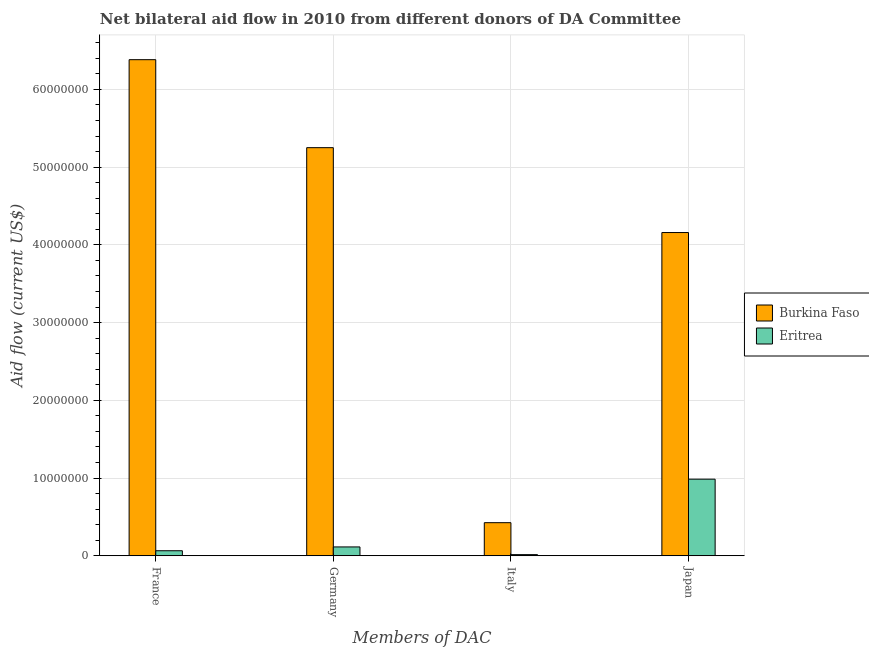How many different coloured bars are there?
Keep it short and to the point. 2. How many groups of bars are there?
Provide a short and direct response. 4. What is the amount of aid given by japan in Burkina Faso?
Your answer should be very brief. 4.16e+07. Across all countries, what is the maximum amount of aid given by japan?
Your response must be concise. 4.16e+07. Across all countries, what is the minimum amount of aid given by japan?
Provide a succinct answer. 9.86e+06. In which country was the amount of aid given by france maximum?
Your answer should be compact. Burkina Faso. In which country was the amount of aid given by japan minimum?
Your answer should be compact. Eritrea. What is the total amount of aid given by france in the graph?
Your response must be concise. 6.45e+07. What is the difference between the amount of aid given by france in Eritrea and that in Burkina Faso?
Your response must be concise. -6.32e+07. What is the difference between the amount of aid given by germany in Burkina Faso and the amount of aid given by japan in Eritrea?
Your answer should be very brief. 4.26e+07. What is the average amount of aid given by france per country?
Give a very brief answer. 3.22e+07. What is the difference between the amount of aid given by france and amount of aid given by japan in Eritrea?
Provide a succinct answer. -9.21e+06. What is the ratio of the amount of aid given by italy in Burkina Faso to that in Eritrea?
Your answer should be compact. 28.4. Is the difference between the amount of aid given by france in Burkina Faso and Eritrea greater than the difference between the amount of aid given by germany in Burkina Faso and Eritrea?
Keep it short and to the point. Yes. What is the difference between the highest and the second highest amount of aid given by france?
Your answer should be very brief. 6.32e+07. What is the difference between the highest and the lowest amount of aid given by italy?
Make the answer very short. 4.11e+06. What does the 2nd bar from the left in France represents?
Your answer should be very brief. Eritrea. What does the 1st bar from the right in Japan represents?
Provide a succinct answer. Eritrea. Is it the case that in every country, the sum of the amount of aid given by france and amount of aid given by germany is greater than the amount of aid given by italy?
Your answer should be compact. Yes. What is the difference between two consecutive major ticks on the Y-axis?
Your response must be concise. 1.00e+07. Are the values on the major ticks of Y-axis written in scientific E-notation?
Your answer should be very brief. No. Does the graph contain grids?
Make the answer very short. Yes. How many legend labels are there?
Make the answer very short. 2. How are the legend labels stacked?
Keep it short and to the point. Vertical. What is the title of the graph?
Give a very brief answer. Net bilateral aid flow in 2010 from different donors of DA Committee. Does "Argentina" appear as one of the legend labels in the graph?
Give a very brief answer. No. What is the label or title of the X-axis?
Keep it short and to the point. Members of DAC. What is the label or title of the Y-axis?
Give a very brief answer. Aid flow (current US$). What is the Aid flow (current US$) in Burkina Faso in France?
Make the answer very short. 6.38e+07. What is the Aid flow (current US$) in Eritrea in France?
Offer a terse response. 6.50e+05. What is the Aid flow (current US$) in Burkina Faso in Germany?
Your answer should be very brief. 5.25e+07. What is the Aid flow (current US$) of Eritrea in Germany?
Give a very brief answer. 1.14e+06. What is the Aid flow (current US$) in Burkina Faso in Italy?
Your answer should be compact. 4.26e+06. What is the Aid flow (current US$) of Eritrea in Italy?
Your answer should be very brief. 1.50e+05. What is the Aid flow (current US$) of Burkina Faso in Japan?
Make the answer very short. 4.16e+07. What is the Aid flow (current US$) in Eritrea in Japan?
Ensure brevity in your answer.  9.86e+06. Across all Members of DAC, what is the maximum Aid flow (current US$) in Burkina Faso?
Offer a terse response. 6.38e+07. Across all Members of DAC, what is the maximum Aid flow (current US$) in Eritrea?
Offer a very short reply. 9.86e+06. Across all Members of DAC, what is the minimum Aid flow (current US$) in Burkina Faso?
Provide a short and direct response. 4.26e+06. Across all Members of DAC, what is the minimum Aid flow (current US$) in Eritrea?
Your response must be concise. 1.50e+05. What is the total Aid flow (current US$) of Burkina Faso in the graph?
Ensure brevity in your answer.  1.62e+08. What is the total Aid flow (current US$) of Eritrea in the graph?
Your response must be concise. 1.18e+07. What is the difference between the Aid flow (current US$) of Burkina Faso in France and that in Germany?
Give a very brief answer. 1.13e+07. What is the difference between the Aid flow (current US$) in Eritrea in France and that in Germany?
Your answer should be compact. -4.90e+05. What is the difference between the Aid flow (current US$) in Burkina Faso in France and that in Italy?
Make the answer very short. 5.96e+07. What is the difference between the Aid flow (current US$) in Eritrea in France and that in Italy?
Offer a very short reply. 5.00e+05. What is the difference between the Aid flow (current US$) in Burkina Faso in France and that in Japan?
Provide a succinct answer. 2.22e+07. What is the difference between the Aid flow (current US$) in Eritrea in France and that in Japan?
Keep it short and to the point. -9.21e+06. What is the difference between the Aid flow (current US$) of Burkina Faso in Germany and that in Italy?
Make the answer very short. 4.82e+07. What is the difference between the Aid flow (current US$) of Eritrea in Germany and that in Italy?
Make the answer very short. 9.90e+05. What is the difference between the Aid flow (current US$) of Burkina Faso in Germany and that in Japan?
Ensure brevity in your answer.  1.09e+07. What is the difference between the Aid flow (current US$) in Eritrea in Germany and that in Japan?
Your answer should be compact. -8.72e+06. What is the difference between the Aid flow (current US$) of Burkina Faso in Italy and that in Japan?
Your response must be concise. -3.73e+07. What is the difference between the Aid flow (current US$) of Eritrea in Italy and that in Japan?
Provide a succinct answer. -9.71e+06. What is the difference between the Aid flow (current US$) of Burkina Faso in France and the Aid flow (current US$) of Eritrea in Germany?
Offer a terse response. 6.27e+07. What is the difference between the Aid flow (current US$) in Burkina Faso in France and the Aid flow (current US$) in Eritrea in Italy?
Keep it short and to the point. 6.37e+07. What is the difference between the Aid flow (current US$) in Burkina Faso in France and the Aid flow (current US$) in Eritrea in Japan?
Offer a very short reply. 5.40e+07. What is the difference between the Aid flow (current US$) of Burkina Faso in Germany and the Aid flow (current US$) of Eritrea in Italy?
Keep it short and to the point. 5.24e+07. What is the difference between the Aid flow (current US$) in Burkina Faso in Germany and the Aid flow (current US$) in Eritrea in Japan?
Provide a short and direct response. 4.26e+07. What is the difference between the Aid flow (current US$) in Burkina Faso in Italy and the Aid flow (current US$) in Eritrea in Japan?
Provide a short and direct response. -5.60e+06. What is the average Aid flow (current US$) in Burkina Faso per Members of DAC?
Your answer should be very brief. 4.05e+07. What is the average Aid flow (current US$) in Eritrea per Members of DAC?
Ensure brevity in your answer.  2.95e+06. What is the difference between the Aid flow (current US$) in Burkina Faso and Aid flow (current US$) in Eritrea in France?
Provide a succinct answer. 6.32e+07. What is the difference between the Aid flow (current US$) in Burkina Faso and Aid flow (current US$) in Eritrea in Germany?
Offer a terse response. 5.14e+07. What is the difference between the Aid flow (current US$) of Burkina Faso and Aid flow (current US$) of Eritrea in Italy?
Your answer should be very brief. 4.11e+06. What is the difference between the Aid flow (current US$) of Burkina Faso and Aid flow (current US$) of Eritrea in Japan?
Provide a short and direct response. 3.17e+07. What is the ratio of the Aid flow (current US$) in Burkina Faso in France to that in Germany?
Keep it short and to the point. 1.22. What is the ratio of the Aid flow (current US$) in Eritrea in France to that in Germany?
Your response must be concise. 0.57. What is the ratio of the Aid flow (current US$) of Burkina Faso in France to that in Italy?
Your answer should be very brief. 14.98. What is the ratio of the Aid flow (current US$) of Eritrea in France to that in Italy?
Keep it short and to the point. 4.33. What is the ratio of the Aid flow (current US$) in Burkina Faso in France to that in Japan?
Your answer should be compact. 1.53. What is the ratio of the Aid flow (current US$) in Eritrea in France to that in Japan?
Offer a terse response. 0.07. What is the ratio of the Aid flow (current US$) in Burkina Faso in Germany to that in Italy?
Your response must be concise. 12.33. What is the ratio of the Aid flow (current US$) in Burkina Faso in Germany to that in Japan?
Offer a terse response. 1.26. What is the ratio of the Aid flow (current US$) in Eritrea in Germany to that in Japan?
Your answer should be very brief. 0.12. What is the ratio of the Aid flow (current US$) in Burkina Faso in Italy to that in Japan?
Keep it short and to the point. 0.1. What is the ratio of the Aid flow (current US$) in Eritrea in Italy to that in Japan?
Your response must be concise. 0.02. What is the difference between the highest and the second highest Aid flow (current US$) in Burkina Faso?
Provide a succinct answer. 1.13e+07. What is the difference between the highest and the second highest Aid flow (current US$) in Eritrea?
Offer a terse response. 8.72e+06. What is the difference between the highest and the lowest Aid flow (current US$) in Burkina Faso?
Provide a short and direct response. 5.96e+07. What is the difference between the highest and the lowest Aid flow (current US$) of Eritrea?
Provide a short and direct response. 9.71e+06. 